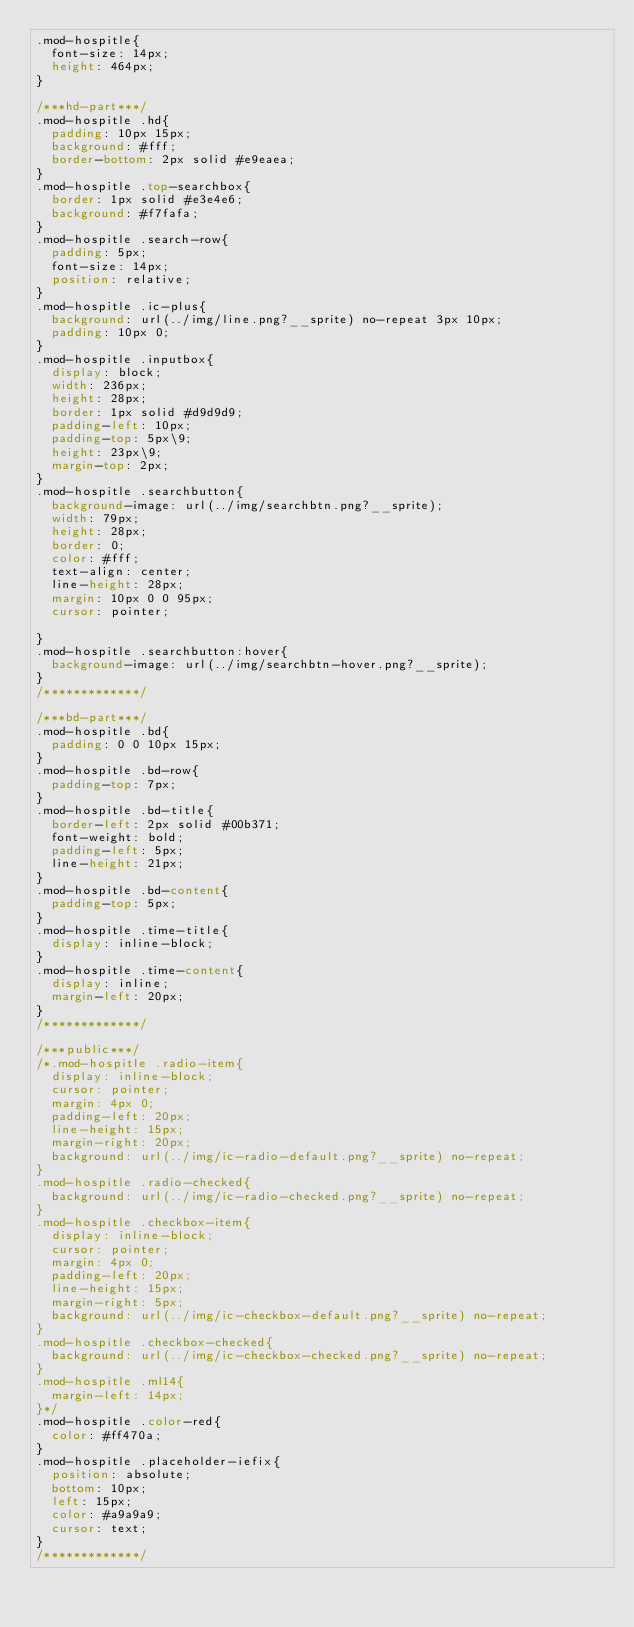Convert code to text. <code><loc_0><loc_0><loc_500><loc_500><_CSS_>.mod-hospitle{
	font-size: 14px;
	height: 464px;
}

/***hd-part***/
.mod-hospitle .hd{
	padding: 10px 15px;
	background: #fff;
	border-bottom: 2px solid #e9eaea;
}
.mod-hospitle .top-searchbox{
	border: 1px solid #e3e4e6;
	background: #f7fafa;
}
.mod-hospitle .search-row{
	padding: 5px;
	font-size: 14px;
	position: relative;
}
.mod-hospitle .ic-plus{
	background: url(../img/line.png?__sprite) no-repeat 3px 10px;
	padding: 10px 0;
}
.mod-hospitle .inputbox{
	display: block;
	width: 236px;
	height: 28px;
	border: 1px solid #d9d9d9;
	padding-left: 10px;
	padding-top: 5px\9;
	height: 23px\9;
	margin-top: 2px;
}
.mod-hospitle .searchbutton{
	background-image: url(../img/searchbtn.png?__sprite);
	width: 79px;
	height: 28px;
	border: 0;
	color: #fff;
	text-align: center;
	line-height: 28px;
	margin: 10px 0 0 95px;
	cursor: pointer;
	
}
.mod-hospitle .searchbutton:hover{
	background-image: url(../img/searchbtn-hover.png?__sprite);
}
/*************/

/***bd-part***/
.mod-hospitle .bd{
	padding: 0 0 10px 15px;
}
.mod-hospitle .bd-row{
	padding-top: 7px;
}
.mod-hospitle .bd-title{
	border-left: 2px solid #00b371;
	font-weight: bold;
	padding-left: 5px;
	line-height: 21px;
}
.mod-hospitle .bd-content{
	padding-top: 5px;
}
.mod-hospitle .time-title{
	display: inline-block;
}
.mod-hospitle .time-content{
	display: inline;
	margin-left: 20px;
}
/*************/

/***public***/
/*.mod-hospitle .radio-item{
	display: inline-block;
	cursor: pointer;
	margin: 4px 0;
	padding-left: 20px;
	line-height: 15px;
	margin-right: 20px;
	background: url(../img/ic-radio-default.png?__sprite) no-repeat;
}
.mod-hospitle .radio-checked{
	background: url(../img/ic-radio-checked.png?__sprite) no-repeat;
}
.mod-hospitle .checkbox-item{
	display: inline-block;
	cursor: pointer;
	margin: 4px 0;
	padding-left: 20px;
	line-height: 15px;
	margin-right: 5px;
	background: url(../img/ic-checkbox-default.png?__sprite) no-repeat;
}
.mod-hospitle .checkbox-checked{
	background: url(../img/ic-checkbox-checked.png?__sprite) no-repeat;
}
.mod-hospitle .ml14{
	margin-left: 14px;
}*/
.mod-hospitle .color-red{
	color: #ff470a;
}
.mod-hospitle .placeholder-iefix{
	position: absolute;
	bottom: 10px;
	left: 15px;
	color: #a9a9a9;
	cursor: text;
}
/*************/
</code> 